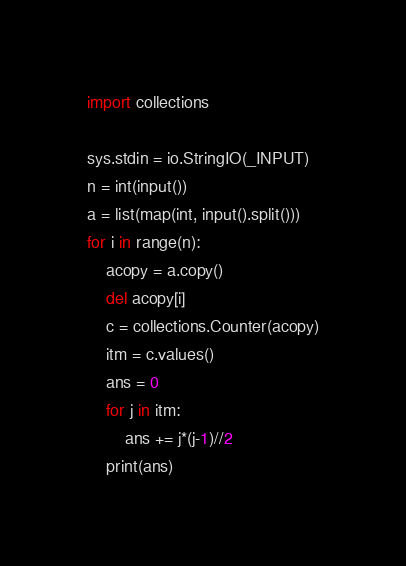Convert code to text. <code><loc_0><loc_0><loc_500><loc_500><_Python_>import collections

sys.stdin = io.StringIO(_INPUT)
n = int(input())
a = list(map(int, input().split()))
for i in range(n):
    acopy = a.copy()
    del acopy[i]
    c = collections.Counter(acopy)
    itm = c.values()
    ans = 0
    for j in itm:
        ans += j*(j-1)//2
    print(ans)</code> 